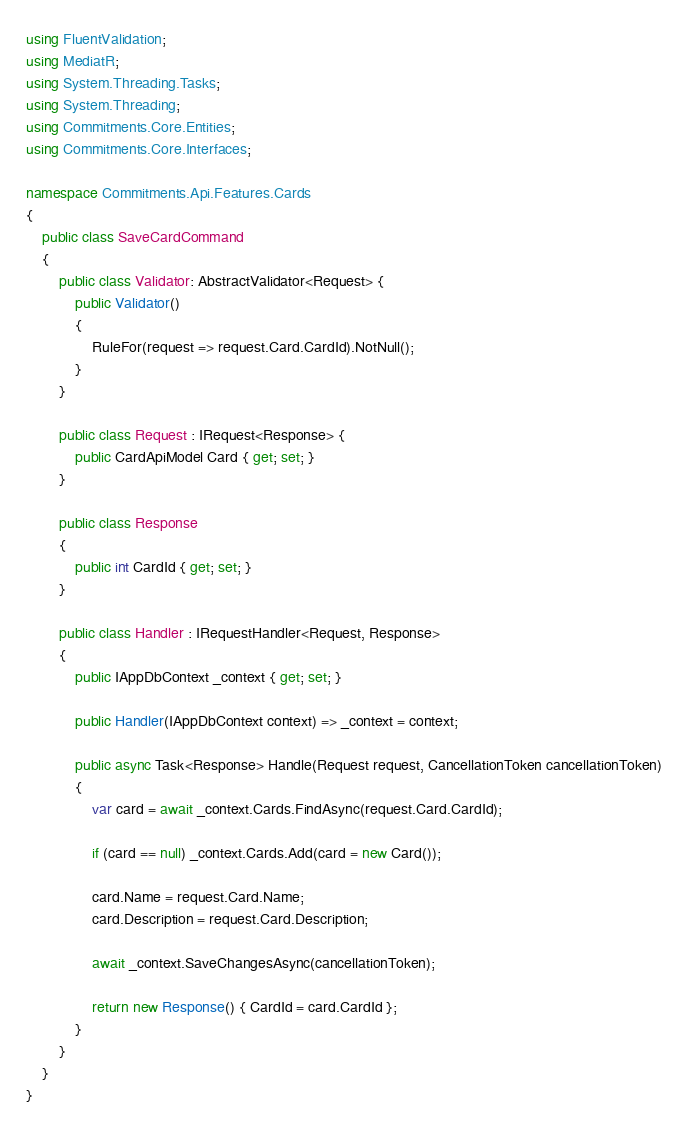<code> <loc_0><loc_0><loc_500><loc_500><_C#_>using FluentValidation;
using MediatR;
using System.Threading.Tasks;
using System.Threading;
using Commitments.Core.Entities;
using Commitments.Core.Interfaces;

namespace Commitments.Api.Features.Cards
{
    public class SaveCardCommand
    {
        public class Validator: AbstractValidator<Request> {
            public Validator()
            {
                RuleFor(request => request.Card.CardId).NotNull();
            }
        }

        public class Request : IRequest<Response> {
            public CardApiModel Card { get; set; }
        }

        public class Response
        {            
            public int CardId { get; set; }
        }

        public class Handler : IRequestHandler<Request, Response>
        {
            public IAppDbContext _context { get; set; }
            
            public Handler(IAppDbContext context) => _context = context;

            public async Task<Response> Handle(Request request, CancellationToken cancellationToken)
            {
                var card = await _context.Cards.FindAsync(request.Card.CardId);

                if (card == null) _context.Cards.Add(card = new Card());

                card.Name = request.Card.Name;
                card.Description = request.Card.Description;

                await _context.SaveChangesAsync(cancellationToken);

                return new Response() { CardId = card.CardId };
            }
        }
    }
}
</code> 